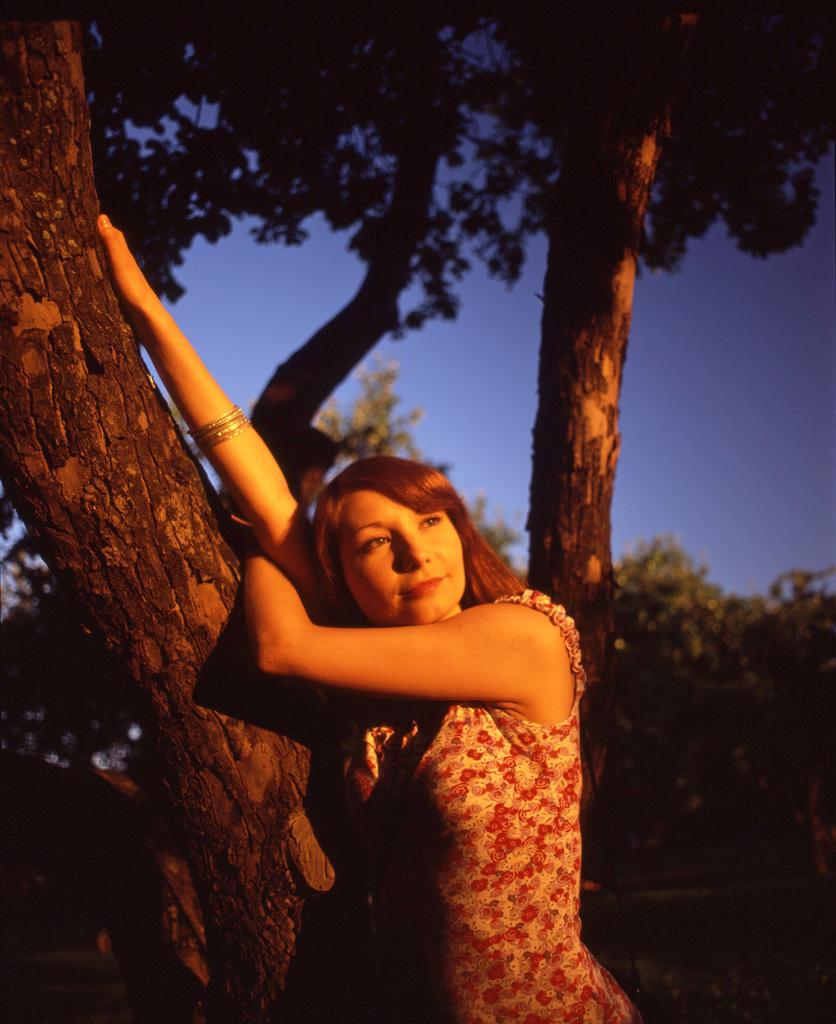Who is present in the image? There is a woman in the image. What is the woman doing in the image? The woman is standing beside the bark of a tree. What can be seen in the background of the image? There are trees and the sky visible in the background of the image. What type of pot is the woman using to start a fire in the image? There is no pot or fire present in the image; the woman is standing beside the bark of a tree. 